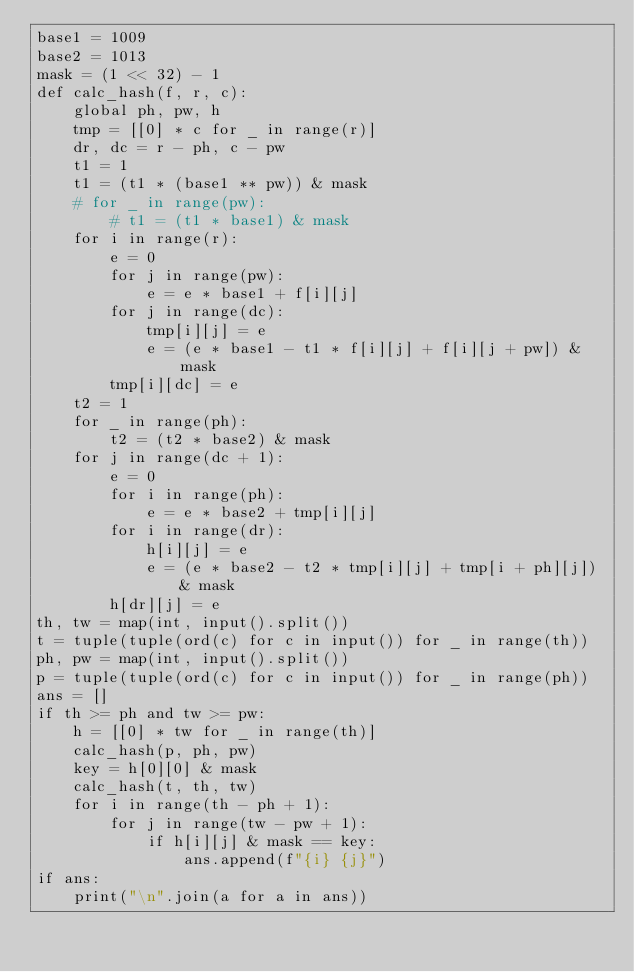<code> <loc_0><loc_0><loc_500><loc_500><_Python_>base1 = 1009
base2 = 1013
mask = (1 << 32) - 1
def calc_hash(f, r, c):
    global ph, pw, h
    tmp = [[0] * c for _ in range(r)]
    dr, dc = r - ph, c - pw
    t1 = 1
	t1 = (t1 * (base1 ** pw)) & mask
    # for _ in range(pw):
        # t1 = (t1 * base1) & mask
    for i in range(r):
        e = 0
        for j in range(pw):
            e = e * base1 + f[i][j]
        for j in range(dc):
            tmp[i][j] = e
            e = (e * base1 - t1 * f[i][j] + f[i][j + pw]) & mask
        tmp[i][dc] = e
    t2 = 1
    for _ in range(ph):
        t2 = (t2 * base2) & mask
    for j in range(dc + 1):
        e = 0
        for i in range(ph):
            e = e * base2 + tmp[i][j]
        for i in range(dr):
            h[i][j] = e
            e = (e * base2 - t2 * tmp[i][j] + tmp[i + ph][j]) & mask
        h[dr][j] = e
th, tw = map(int, input().split())
t = tuple(tuple(ord(c) for c in input()) for _ in range(th))
ph, pw = map(int, input().split())
p = tuple(tuple(ord(c) for c in input()) for _ in range(ph))
ans = []
if th >= ph and tw >= pw:
    h = [[0] * tw for _ in range(th)]
    calc_hash(p, ph, pw)
    key = h[0][0] & mask
    calc_hash(t, th, tw)
    for i in range(th - ph + 1):
        for j in range(tw - pw + 1):
            if h[i][j] & mask == key:
                ans.append(f"{i} {j}")
if ans:
    print("\n".join(a for a in ans))
</code> 